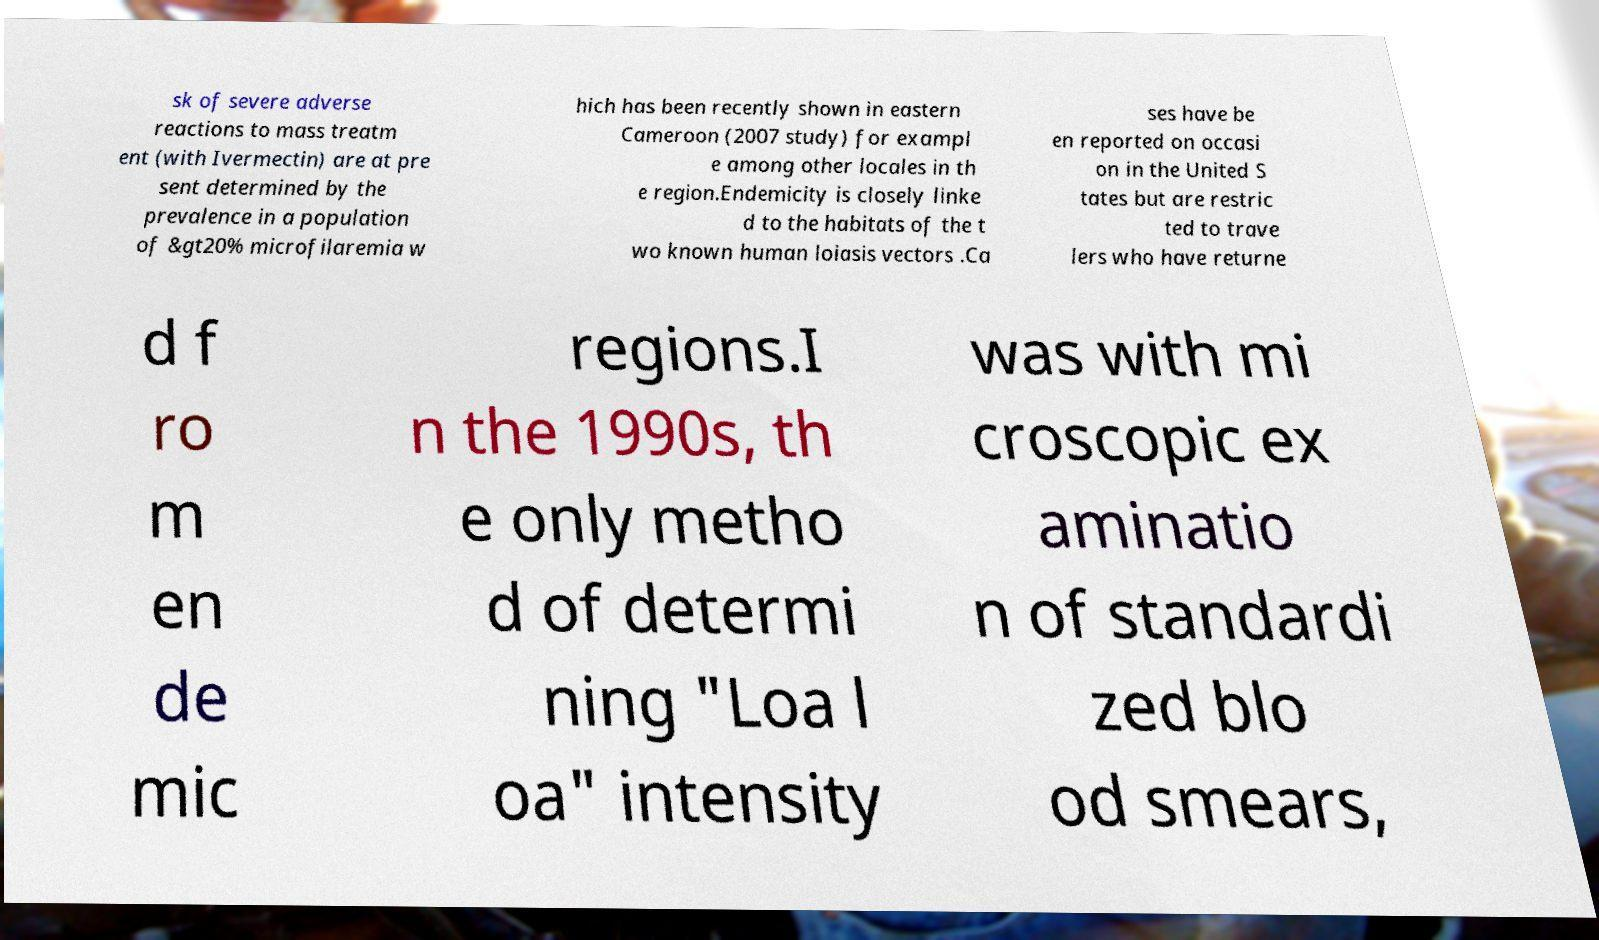Could you assist in decoding the text presented in this image and type it out clearly? sk of severe adverse reactions to mass treatm ent (with Ivermectin) are at pre sent determined by the prevalence in a population of &gt20% microfilaremia w hich has been recently shown in eastern Cameroon (2007 study) for exampl e among other locales in th e region.Endemicity is closely linke d to the habitats of the t wo known human loiasis vectors .Ca ses have be en reported on occasi on in the United S tates but are restric ted to trave lers who have returne d f ro m en de mic regions.I n the 1990s, th e only metho d of determi ning "Loa l oa" intensity was with mi croscopic ex aminatio n of standardi zed blo od smears, 